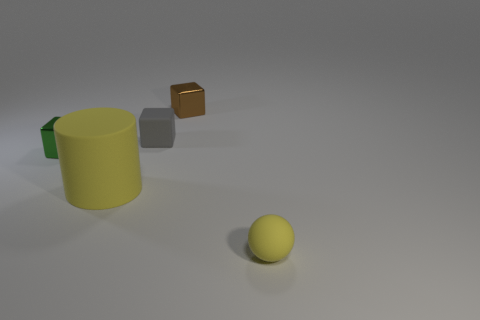Could you describe the lighting and shadowing in the scene? Certainly, the lighting in the scene appears to come from the upper left, as indicated by the shadows cast to the lower right of the objects. It's a soft light, which creates diffuse shadows with soft edges rather than crisp, hard lines. This suggests either a dim light source or one that is being filtered, such as through a cloudy atmosphere or a semi-opaque shade. The ambient lighting also adds to the sense of depth, contributing to the three-dimensional rendering of the objects. 